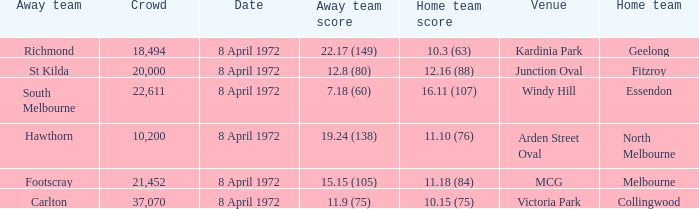Which Home team score has a Home team of geelong? 10.3 (63). 